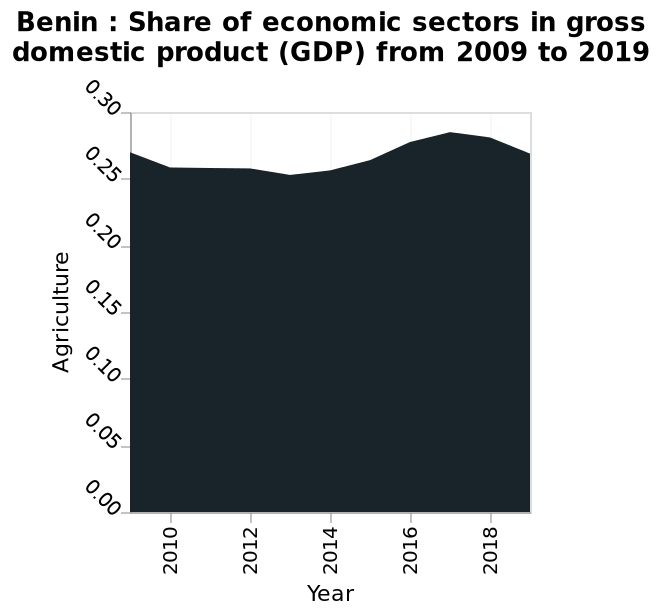<image>
What is the maximum value for the agriculture sector's share of GDP? The maximum value for the agriculture sector's share of GDP is 0.28. What is the range of years represented on the x-axis?  The range of years represented on the x-axis is from 2009 to 2019. 